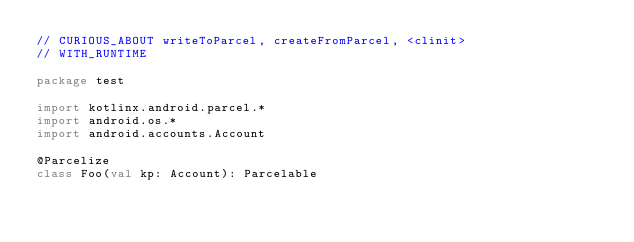<code> <loc_0><loc_0><loc_500><loc_500><_Kotlin_>// CURIOUS_ABOUT writeToParcel, createFromParcel, <clinit>
// WITH_RUNTIME

package test

import kotlinx.android.parcel.*
import android.os.*
import android.accounts.Account

@Parcelize
class Foo(val kp: Account): Parcelable</code> 